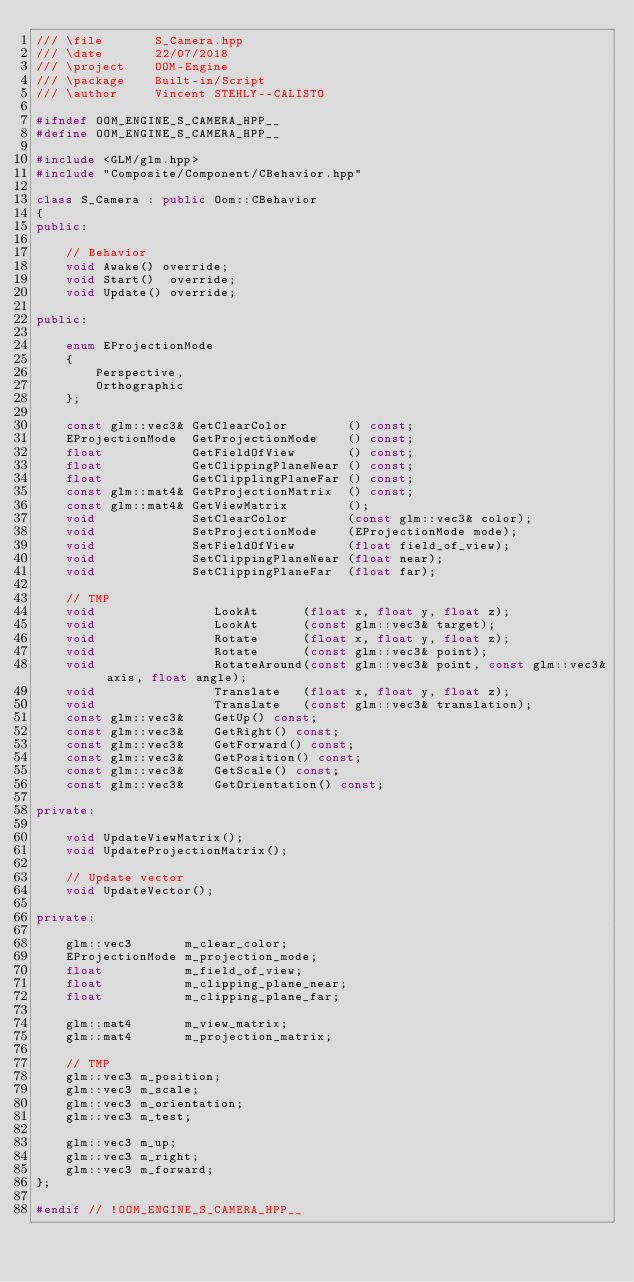Convert code to text. <code><loc_0><loc_0><loc_500><loc_500><_C++_>/// \file       S_Camera.hpp
/// \date       22/07/2018 
/// \project    OOM-Engine
/// \package    Built-in/Script
/// \author     Vincent STEHLY--CALISTO

#ifndef OOM_ENGINE_S_CAMERA_HPP__
#define OOM_ENGINE_S_CAMERA_HPP__

#include <GLM/glm.hpp>
#include "Composite/Component/CBehavior.hpp"

class S_Camera : public Oom::CBehavior
{
public:

    // Behavior
	void Awake() override;
    void Start()  override;
    void Update() override;

public:

    enum EProjectionMode
    {
        Perspective,
        Orthographic
    };

    const glm::vec3& GetClearColor        () const;
    EProjectionMode  GetProjectionMode    () const;
    float            GetFieldOfView       () const;
    float            GetClippingPlaneNear () const;
    float            GetClipplingPlaneFar () const;
    const glm::mat4& GetProjectionMatrix  () const;
    const glm::mat4& GetViewMatrix        ();
    void             SetClearColor        (const glm::vec3& color);
    void             SetProjectionMode    (EProjectionMode mode);
    void             SetFieldOfView       (float field_of_view);
    void             SetClippingPlaneNear (float near);
    void             SetClippingPlaneFar  (float far);

	// TMP
	void				LookAt      (float x, float y, float z);
	void				LookAt      (const glm::vec3& target);
	void                Rotate      (float x, float y, float z);
	void                Rotate      (const glm::vec3& point);
	void                RotateAround(const glm::vec3& point, const glm::vec3& axis, float angle);
	void                Translate   (float x, float y, float z);
	void                Translate   (const glm::vec3& translation);
	const glm::vec3&    GetUp() const;
	const glm::vec3&    GetRight() const;
	const glm::vec3&    GetForward() const;
	const glm::vec3&    GetPosition() const;
	const glm::vec3&    GetScale() const;
	const glm::vec3&    GetOrientation() const;

private:

    void UpdateViewMatrix();
    void UpdateProjectionMatrix();

	// Update vector
	void UpdateVector();

private:

    glm::vec3       m_clear_color;
    EProjectionMode m_projection_mode;
    float           m_field_of_view;
    float           m_clipping_plane_near;
    float           m_clipping_plane_far;

    glm::mat4       m_view_matrix;
    glm::mat4       m_projection_matrix;

	// TMP
	glm::vec3 m_position;
	glm::vec3 m_scale;
	glm::vec3 m_orientation;
	glm::vec3 m_test;

	glm::vec3 m_up;
	glm::vec3 m_right;
	glm::vec3 m_forward;
};

#endif // !OOM_ENGINE_S_CAMERA_HPP__</code> 